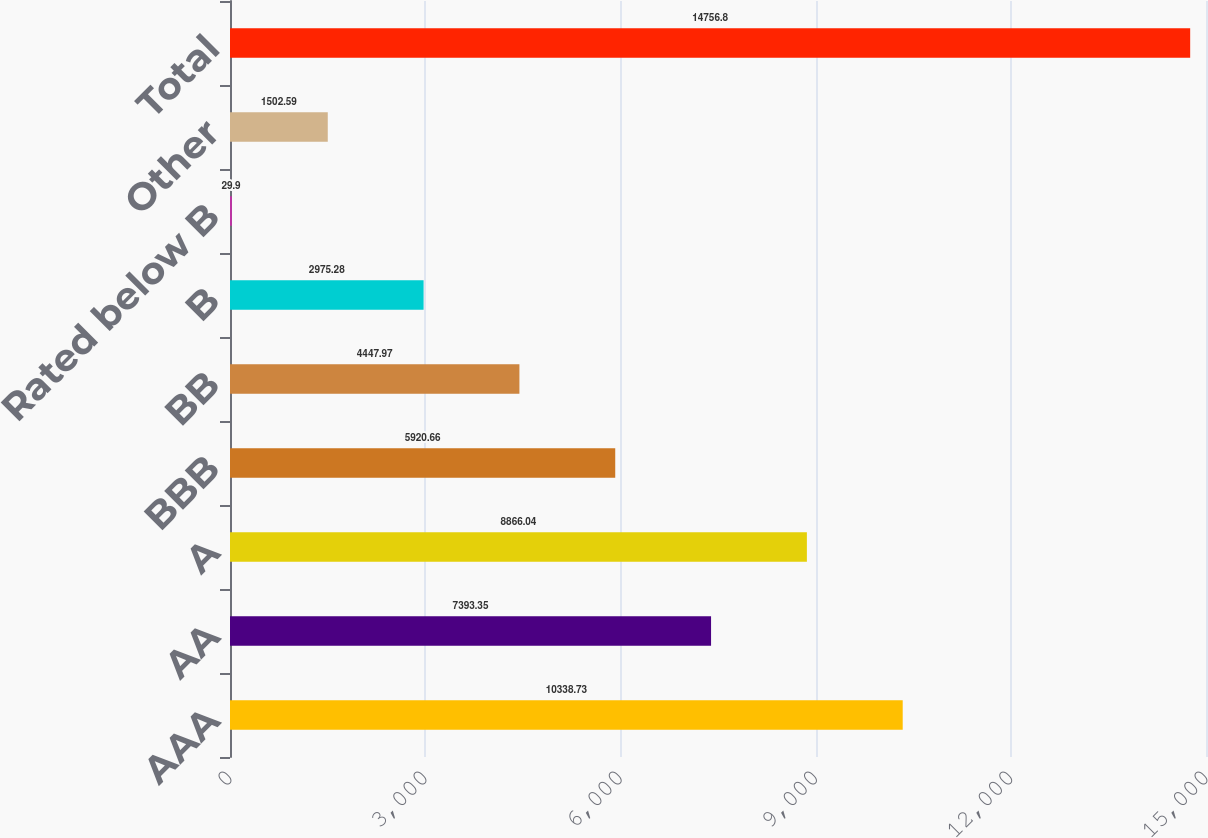Convert chart. <chart><loc_0><loc_0><loc_500><loc_500><bar_chart><fcel>AAA<fcel>AA<fcel>A<fcel>BBB<fcel>BB<fcel>B<fcel>Rated below B<fcel>Other<fcel>Total<nl><fcel>10338.7<fcel>7393.35<fcel>8866.04<fcel>5920.66<fcel>4447.97<fcel>2975.28<fcel>29.9<fcel>1502.59<fcel>14756.8<nl></chart> 